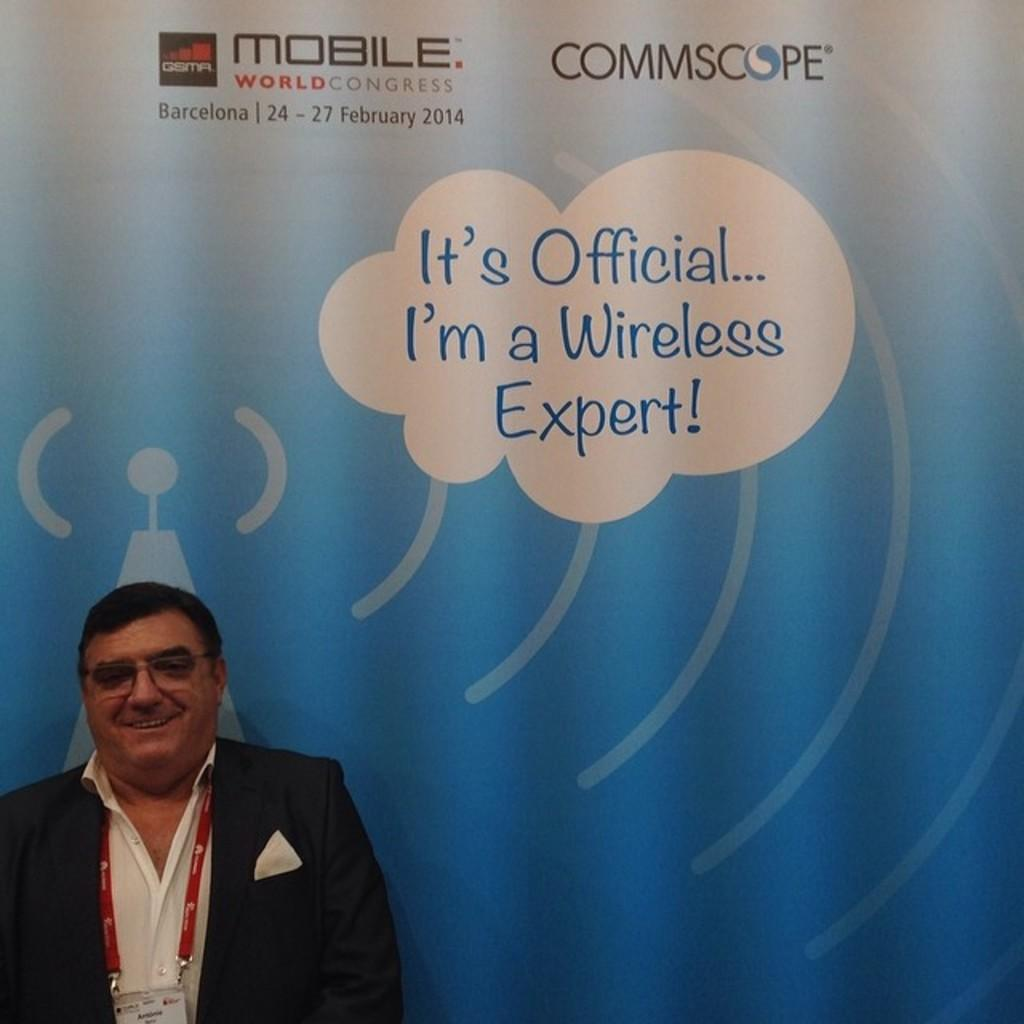<image>
Present a compact description of the photo's key features. Man standing in front of a wall that says "It's Official, I'm a wireless expert!". 